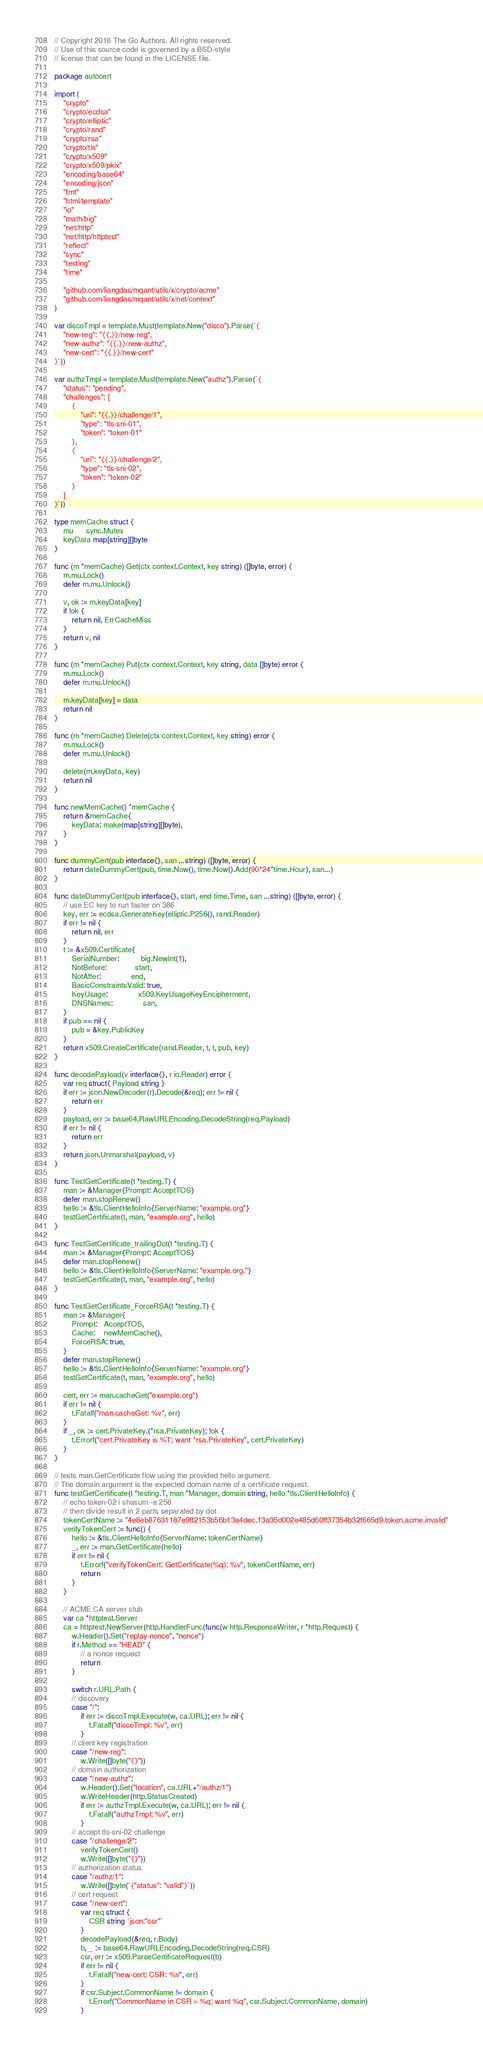<code> <loc_0><loc_0><loc_500><loc_500><_Go_>// Copyright 2016 The Go Authors. All rights reserved.
// Use of this source code is governed by a BSD-style
// license that can be found in the LICENSE file.

package autocert

import (
	"crypto"
	"crypto/ecdsa"
	"crypto/elliptic"
	"crypto/rand"
	"crypto/rsa"
	"crypto/tls"
	"crypto/x509"
	"crypto/x509/pkix"
	"encoding/base64"
	"encoding/json"
	"fmt"
	"html/template"
	"io"
	"math/big"
	"net/http"
	"net/http/httptest"
	"reflect"
	"sync"
	"testing"
	"time"

	"github.com/liangdas/mqant/utils/x/crypto/acme"
	"github.com/liangdas/mqant/utils/x/net/context"
)

var discoTmpl = template.Must(template.New("disco").Parse(`{
	"new-reg": "{{.}}/new-reg",
	"new-authz": "{{.}}/new-authz",
	"new-cert": "{{.}}/new-cert"
}`))

var authzTmpl = template.Must(template.New("authz").Parse(`{
	"status": "pending",
	"challenges": [
		{
			"uri": "{{.}}/challenge/1",
			"type": "tls-sni-01",
			"token": "token-01"
		},
		{
			"uri": "{{.}}/challenge/2",
			"type": "tls-sni-02",
			"token": "token-02"
		}
	]
}`))

type memCache struct {
	mu      sync.Mutex
	keyData map[string][]byte
}

func (m *memCache) Get(ctx context.Context, key string) ([]byte, error) {
	m.mu.Lock()
	defer m.mu.Unlock()

	v, ok := m.keyData[key]
	if !ok {
		return nil, ErrCacheMiss
	}
	return v, nil
}

func (m *memCache) Put(ctx context.Context, key string, data []byte) error {
	m.mu.Lock()
	defer m.mu.Unlock()

	m.keyData[key] = data
	return nil
}

func (m *memCache) Delete(ctx context.Context, key string) error {
	m.mu.Lock()
	defer m.mu.Unlock()

	delete(m.keyData, key)
	return nil
}

func newMemCache() *memCache {
	return &memCache{
		keyData: make(map[string][]byte),
	}
}

func dummyCert(pub interface{}, san ...string) ([]byte, error) {
	return dateDummyCert(pub, time.Now(), time.Now().Add(90*24*time.Hour), san...)
}

func dateDummyCert(pub interface{}, start, end time.Time, san ...string) ([]byte, error) {
	// use EC key to run faster on 386
	key, err := ecdsa.GenerateKey(elliptic.P256(), rand.Reader)
	if err != nil {
		return nil, err
	}
	t := &x509.Certificate{
		SerialNumber:          big.NewInt(1),
		NotBefore:             start,
		NotAfter:              end,
		BasicConstraintsValid: true,
		KeyUsage:              x509.KeyUsageKeyEncipherment,
		DNSNames:              san,
	}
	if pub == nil {
		pub = &key.PublicKey
	}
	return x509.CreateCertificate(rand.Reader, t, t, pub, key)
}

func decodePayload(v interface{}, r io.Reader) error {
	var req struct{ Payload string }
	if err := json.NewDecoder(r).Decode(&req); err != nil {
		return err
	}
	payload, err := base64.RawURLEncoding.DecodeString(req.Payload)
	if err != nil {
		return err
	}
	return json.Unmarshal(payload, v)
}

func TestGetCertificate(t *testing.T) {
	man := &Manager{Prompt: AcceptTOS}
	defer man.stopRenew()
	hello := &tls.ClientHelloInfo{ServerName: "example.org"}
	testGetCertificate(t, man, "example.org", hello)
}

func TestGetCertificate_trailingDot(t *testing.T) {
	man := &Manager{Prompt: AcceptTOS}
	defer man.stopRenew()
	hello := &tls.ClientHelloInfo{ServerName: "example.org."}
	testGetCertificate(t, man, "example.org", hello)
}

func TestGetCertificate_ForceRSA(t *testing.T) {
	man := &Manager{
		Prompt:   AcceptTOS,
		Cache:    newMemCache(),
		ForceRSA: true,
	}
	defer man.stopRenew()
	hello := &tls.ClientHelloInfo{ServerName: "example.org"}
	testGetCertificate(t, man, "example.org", hello)

	cert, err := man.cacheGet("example.org")
	if err != nil {
		t.Fatalf("man.cacheGet: %v", err)
	}
	if _, ok := cert.PrivateKey.(*rsa.PrivateKey); !ok {
		t.Errorf("cert.PrivateKey is %T; want *rsa.PrivateKey", cert.PrivateKey)
	}
}

// tests man.GetCertificate flow using the provided hello argument.
// The domain argument is the expected domain name of a certificate request.
func testGetCertificate(t *testing.T, man *Manager, domain string, hello *tls.ClientHelloInfo) {
	// echo token-02 | shasum -a 256
	// then divide result in 2 parts separated by dot
	tokenCertName := "4e8eb87631187e9ff2153b56b13a4dec.13a35d002e485d60ff37354b32f665d9.token.acme.invalid"
	verifyTokenCert := func() {
		hello := &tls.ClientHelloInfo{ServerName: tokenCertName}
		_, err := man.GetCertificate(hello)
		if err != nil {
			t.Errorf("verifyTokenCert: GetCertificate(%q): %v", tokenCertName, err)
			return
		}
	}

	// ACME CA server stub
	var ca *httptest.Server
	ca = httptest.NewServer(http.HandlerFunc(func(w http.ResponseWriter, r *http.Request) {
		w.Header().Set("replay-nonce", "nonce")
		if r.Method == "HEAD" {
			// a nonce request
			return
		}

		switch r.URL.Path {
		// discovery
		case "/":
			if err := discoTmpl.Execute(w, ca.URL); err != nil {
				t.Fatalf("discoTmpl: %v", err)
			}
		// client key registration
		case "/new-reg":
			w.Write([]byte("{}"))
		// domain authorization
		case "/new-authz":
			w.Header().Set("location", ca.URL+"/authz/1")
			w.WriteHeader(http.StatusCreated)
			if err := authzTmpl.Execute(w, ca.URL); err != nil {
				t.Fatalf("authzTmpl: %v", err)
			}
		// accept tls-sni-02 challenge
		case "/challenge/2":
			verifyTokenCert()
			w.Write([]byte("{}"))
		// authorization status
		case "/authz/1":
			w.Write([]byte(`{"status": "valid"}`))
		// cert request
		case "/new-cert":
			var req struct {
				CSR string `json:"csr"`
			}
			decodePayload(&req, r.Body)
			b, _ := base64.RawURLEncoding.DecodeString(req.CSR)
			csr, err := x509.ParseCertificateRequest(b)
			if err != nil {
				t.Fatalf("new-cert: CSR: %v", err)
			}
			if csr.Subject.CommonName != domain {
				t.Errorf("CommonName in CSR = %q; want %q", csr.Subject.CommonName, domain)
			}</code> 